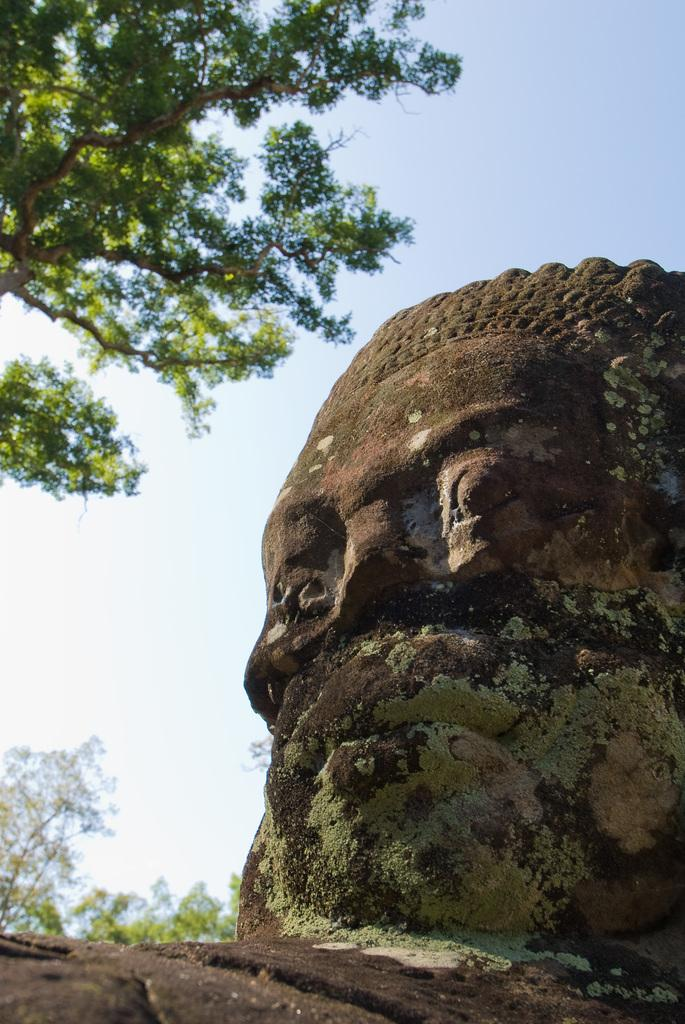What is the main subject of the image? There is a sculpture in the image. What type of natural elements can be seen in the image? There are trees in the image. What can be seen in the background of the image? The sky is visible in the background of the image. What type of shirt is the chair wearing in the image? There is no chair or shirt present in the image; it features a sculpture and trees. 